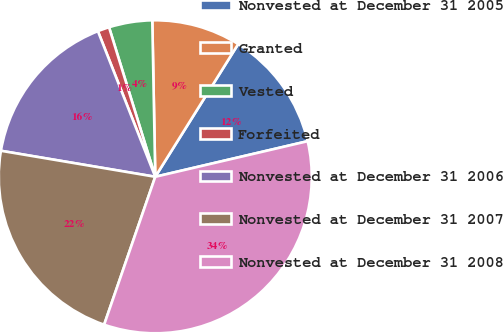Convert chart. <chart><loc_0><loc_0><loc_500><loc_500><pie_chart><fcel>Nonvested at December 31 2005<fcel>Granted<fcel>Vested<fcel>Forfeited<fcel>Nonvested at December 31 2006<fcel>Nonvested at December 31 2007<fcel>Nonvested at December 31 2008<nl><fcel>12.46%<fcel>9.19%<fcel>4.47%<fcel>1.2%<fcel>16.37%<fcel>22.36%<fcel>33.95%<nl></chart> 